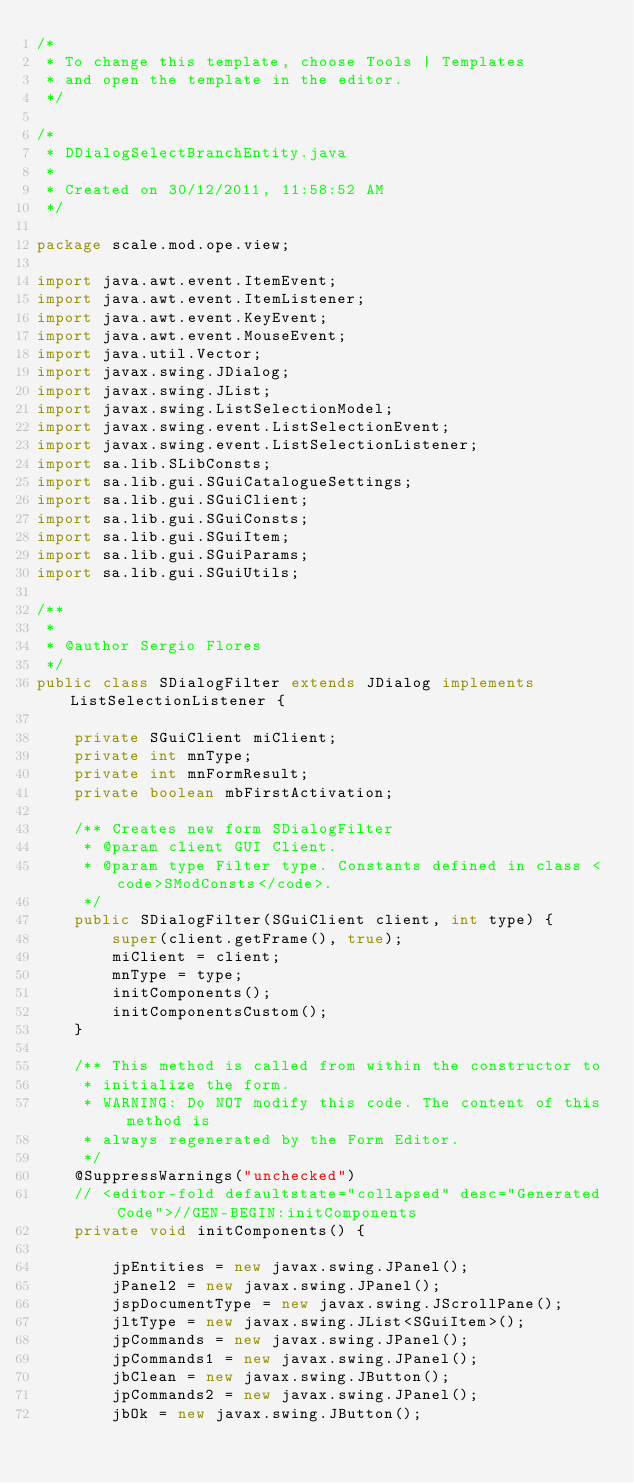<code> <loc_0><loc_0><loc_500><loc_500><_Java_>/*
 * To change this template, choose Tools | Templates
 * and open the template in the editor.
 */

/*
 * DDialogSelectBranchEntity.java
 *
 * Created on 30/12/2011, 11:58:52 AM
 */

package scale.mod.ope.view;

import java.awt.event.ItemEvent;
import java.awt.event.ItemListener;
import java.awt.event.KeyEvent;
import java.awt.event.MouseEvent;
import java.util.Vector;
import javax.swing.JDialog;
import javax.swing.JList;
import javax.swing.ListSelectionModel;
import javax.swing.event.ListSelectionEvent;
import javax.swing.event.ListSelectionListener;
import sa.lib.SLibConsts;
import sa.lib.gui.SGuiCatalogueSettings;
import sa.lib.gui.SGuiClient;
import sa.lib.gui.SGuiConsts;
import sa.lib.gui.SGuiItem;
import sa.lib.gui.SGuiParams;
import sa.lib.gui.SGuiUtils;

/**
 *
 * @author Sergio Flores
 */
public class SDialogFilter extends JDialog implements ListSelectionListener {

    private SGuiClient miClient;
    private int mnType;
    private int mnFormResult;
    private boolean mbFirstActivation;

    /** Creates new form SDialogFilter
     * @param client GUI Client.
     * @param type Filter type. Constants defined in class <code>SModConsts</code>.
     */
    public SDialogFilter(SGuiClient client, int type) {
        super(client.getFrame(), true);
        miClient = client;
        mnType = type;
        initComponents();
        initComponentsCustom();
    }

    /** This method is called from within the constructor to
     * initialize the form.
     * WARNING: Do NOT modify this code. The content of this method is
     * always regenerated by the Form Editor.
     */
    @SuppressWarnings("unchecked")
    // <editor-fold defaultstate="collapsed" desc="Generated Code">//GEN-BEGIN:initComponents
    private void initComponents() {

        jpEntities = new javax.swing.JPanel();
        jPanel2 = new javax.swing.JPanel();
        jspDocumentType = new javax.swing.JScrollPane();
        jltType = new javax.swing.JList<SGuiItem>();
        jpCommands = new javax.swing.JPanel();
        jpCommands1 = new javax.swing.JPanel();
        jbClean = new javax.swing.JButton();
        jpCommands2 = new javax.swing.JPanel();
        jbOk = new javax.swing.JButton();</code> 